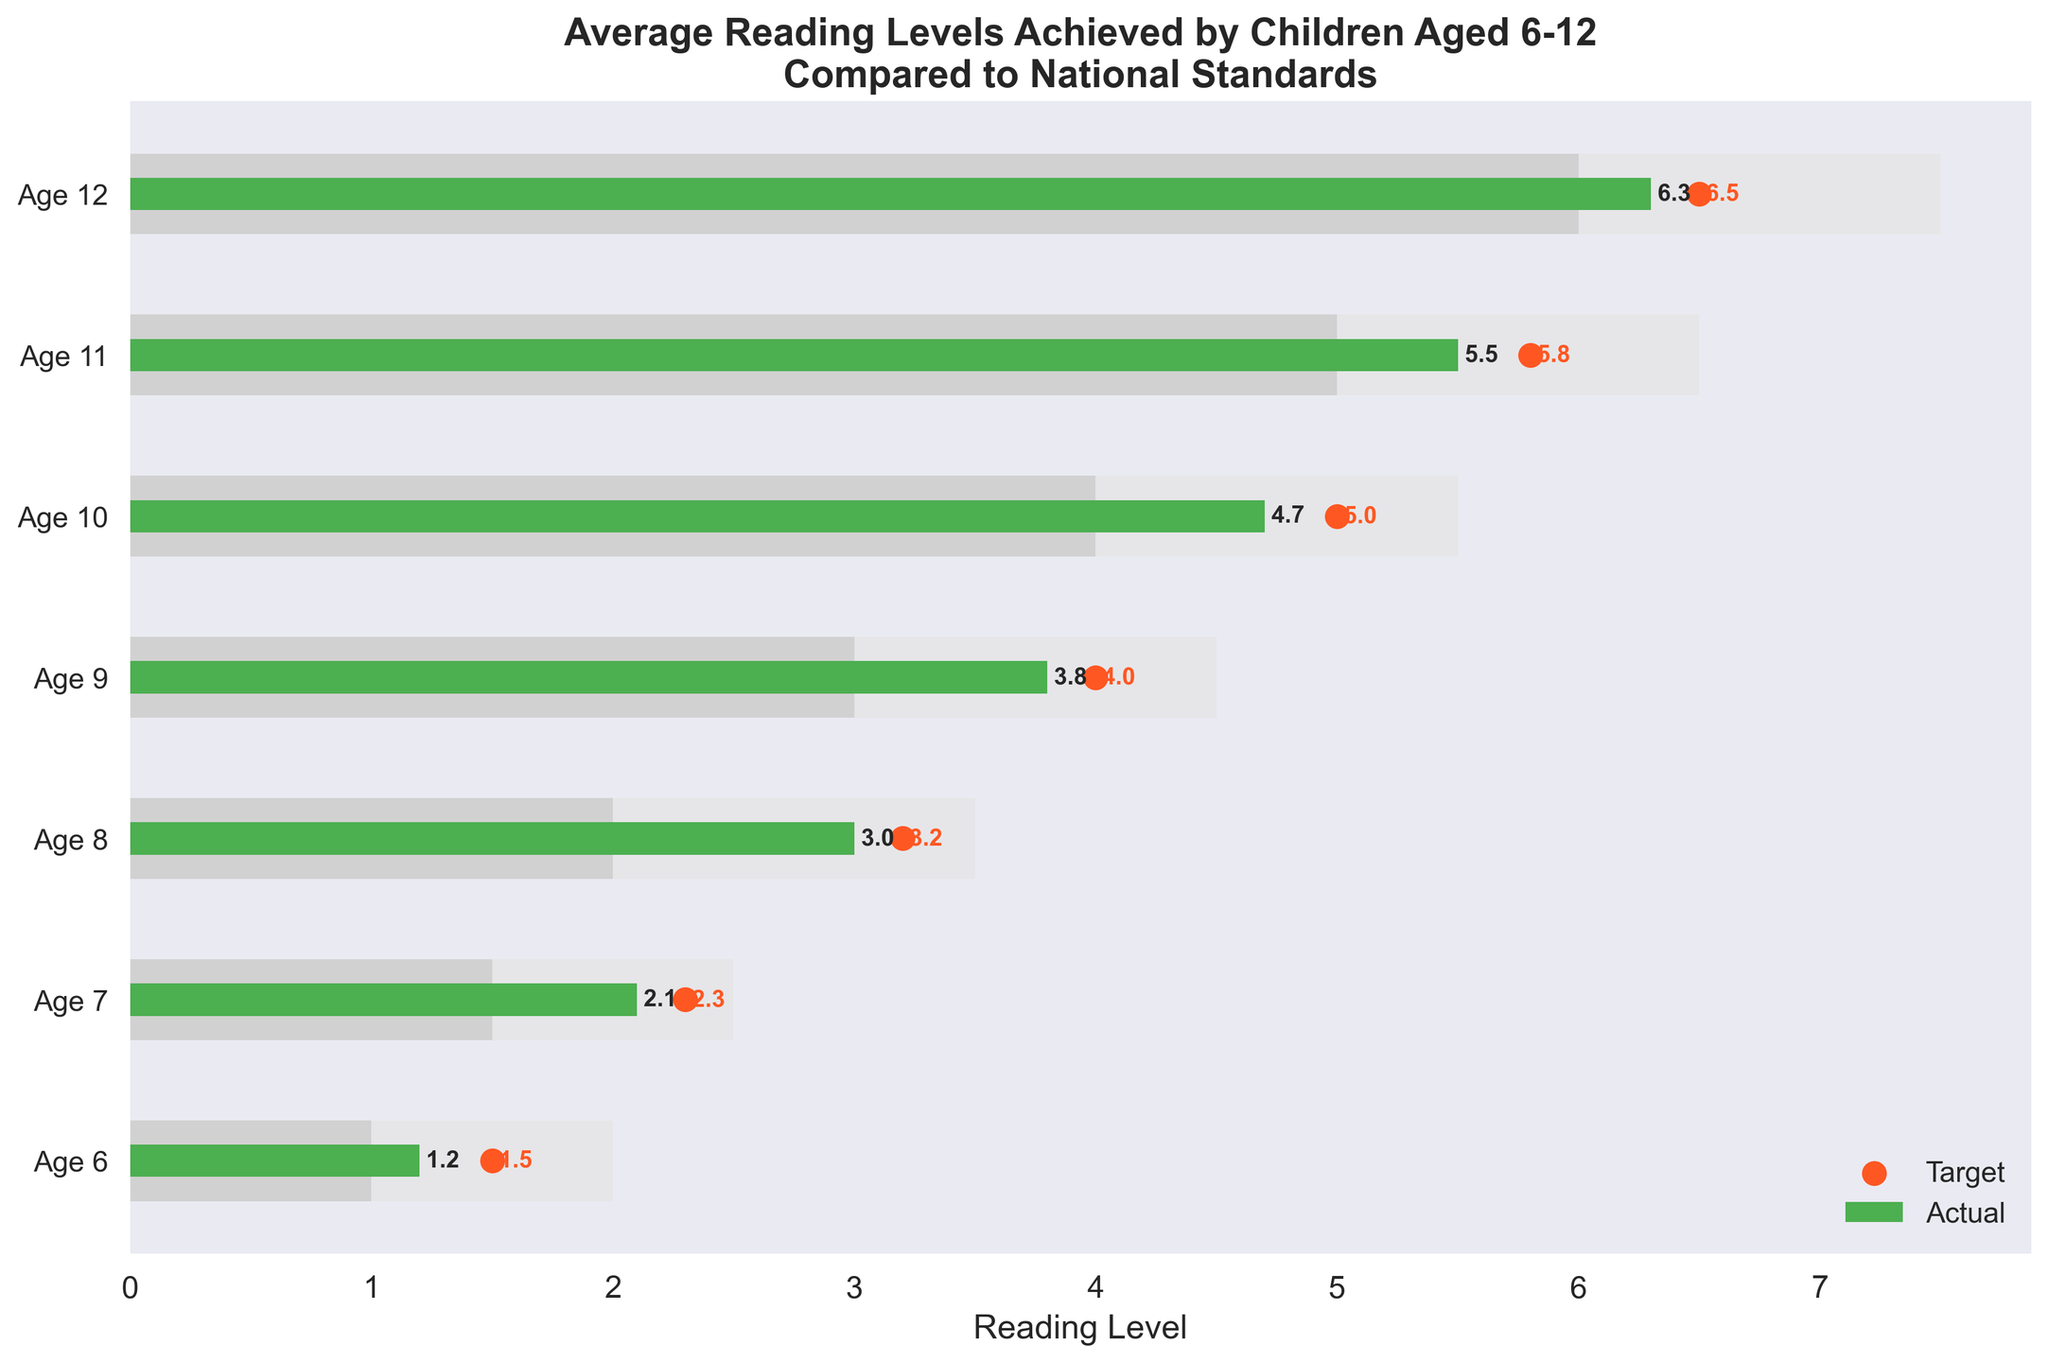How many age categories are there in the plot? By counting the number of y-tick labels on the left side of the plot, we observe that there are 7 categories from Age 6 to Age 12.
Answer: 7 What is the target reading level for Age 10? Locate the point marked by a dot on the horizontal line corresponding to Age 10, and then read its value.
Answer: 5.0 Which age group has achieved the highest actual reading level? By comparing the green bars' extents for all age groups, we can see that Age 12 has the longest green bar, signifying the highest actual reading level.
Answer: Age 12 For Age 8, is the actual reading level above or below the satisfactory range? The satisfactory range for Age 8 is marked by a light gray bar extending from 2 to 3.5. The green bar representing the actual reading level reaches 3.0, which lies within this range.
Answer: Within How does the actual reading level for Age 9 compare to its target? The actual reading level of 3.8 for Age 9 can be compared to its target of 4.0, showing that the actual reading level is slightly below the target.
Answer: Below Which age group has the smallest difference between the actual reading level and the target? Calculate the differences between actual levels and targets for all age groups. For Age 6: 0.3, Age 7: 0.2, Age 8: 0.2, Age 9: 0.2, Age 10: 0.3, Age 11: 0.3, Age 12: 0.2. Age 8, Age 7, Age 9, and Age 12 have the smallest difference (0.2).
Answer: Age 7, Age 8, Age 9, Age 12 What is the range of 'good' reading levels for Age 11? The lightest gray bar for Age 11 extends from 0 to 6.5, indicating the range for 'good' reading levels.
Answer: 0 to 6.5 Which reading level categories fall entirely within the 'poor' range for any age group? The 'poor' range is represented by the dark gray bar at the bottom. For all age groups, the dark gray bar extends from 0 to a value, none of the actual reading levels fall entirely within this range.
Answer: None What trend can be observed when comparing actual reading levels against targets across all age groups? When observing the positions of the green bars (actual) and the dots (targets) for each age group, we notice that actual reading levels generally fall slightly below their targets across all age groups.
Answer: Reading levels fall generally below targets 